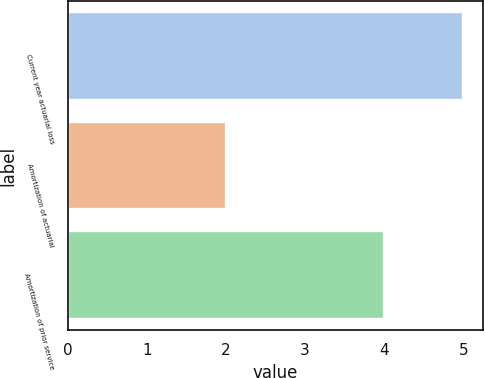Convert chart. <chart><loc_0><loc_0><loc_500><loc_500><bar_chart><fcel>Current year actuarial loss<fcel>Amortization of actuarial<fcel>Amortization of prior service<nl><fcel>5<fcel>2<fcel>4<nl></chart> 